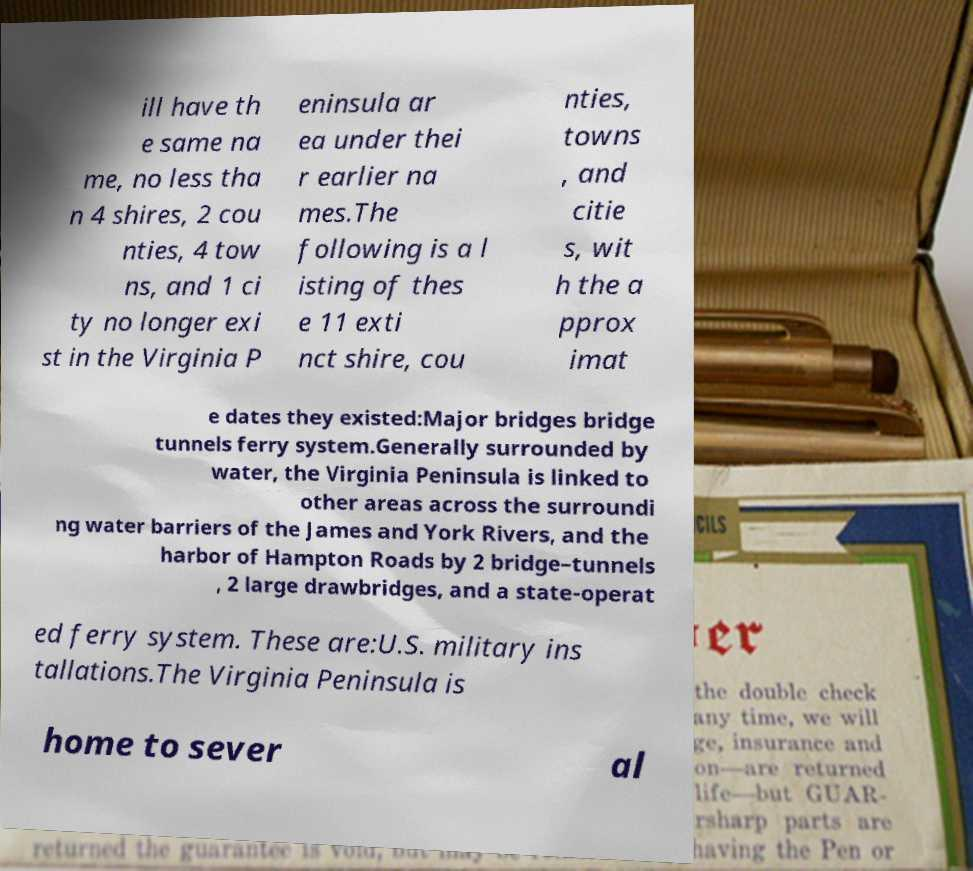Please identify and transcribe the text found in this image. ill have th e same na me, no less tha n 4 shires, 2 cou nties, 4 tow ns, and 1 ci ty no longer exi st in the Virginia P eninsula ar ea under thei r earlier na mes.The following is a l isting of thes e 11 exti nct shire, cou nties, towns , and citie s, wit h the a pprox imat e dates they existed:Major bridges bridge tunnels ferry system.Generally surrounded by water, the Virginia Peninsula is linked to other areas across the surroundi ng water barriers of the James and York Rivers, and the harbor of Hampton Roads by 2 bridge–tunnels , 2 large drawbridges, and a state-operat ed ferry system. These are:U.S. military ins tallations.The Virginia Peninsula is home to sever al 